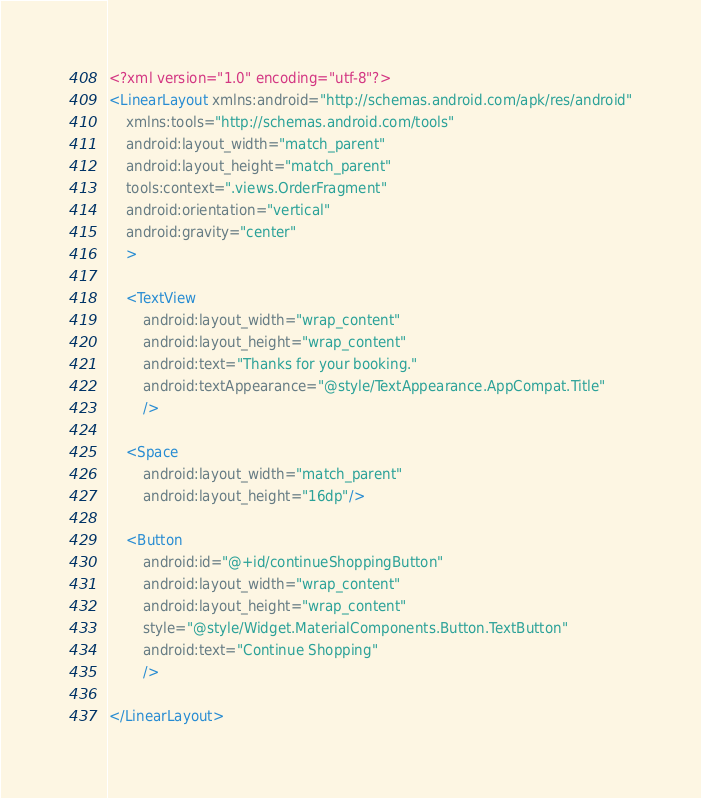Convert code to text. <code><loc_0><loc_0><loc_500><loc_500><_XML_><?xml version="1.0" encoding="utf-8"?>
<LinearLayout xmlns:android="http://schemas.android.com/apk/res/android"
    xmlns:tools="http://schemas.android.com/tools"
    android:layout_width="match_parent"
    android:layout_height="match_parent"
    tools:context=".views.OrderFragment"
    android:orientation="vertical"
    android:gravity="center"
    >

    <TextView
        android:layout_width="wrap_content"
        android:layout_height="wrap_content"
        android:text="Thanks for your booking."
        android:textAppearance="@style/TextAppearance.AppCompat.Title"
        />

    <Space
        android:layout_width="match_parent"
        android:layout_height="16dp"/>

    <Button
        android:id="@+id/continueShoppingButton"
        android:layout_width="wrap_content"
        android:layout_height="wrap_content"
        style="@style/Widget.MaterialComponents.Button.TextButton"
        android:text="Continue Shopping"
        />

</LinearLayout></code> 